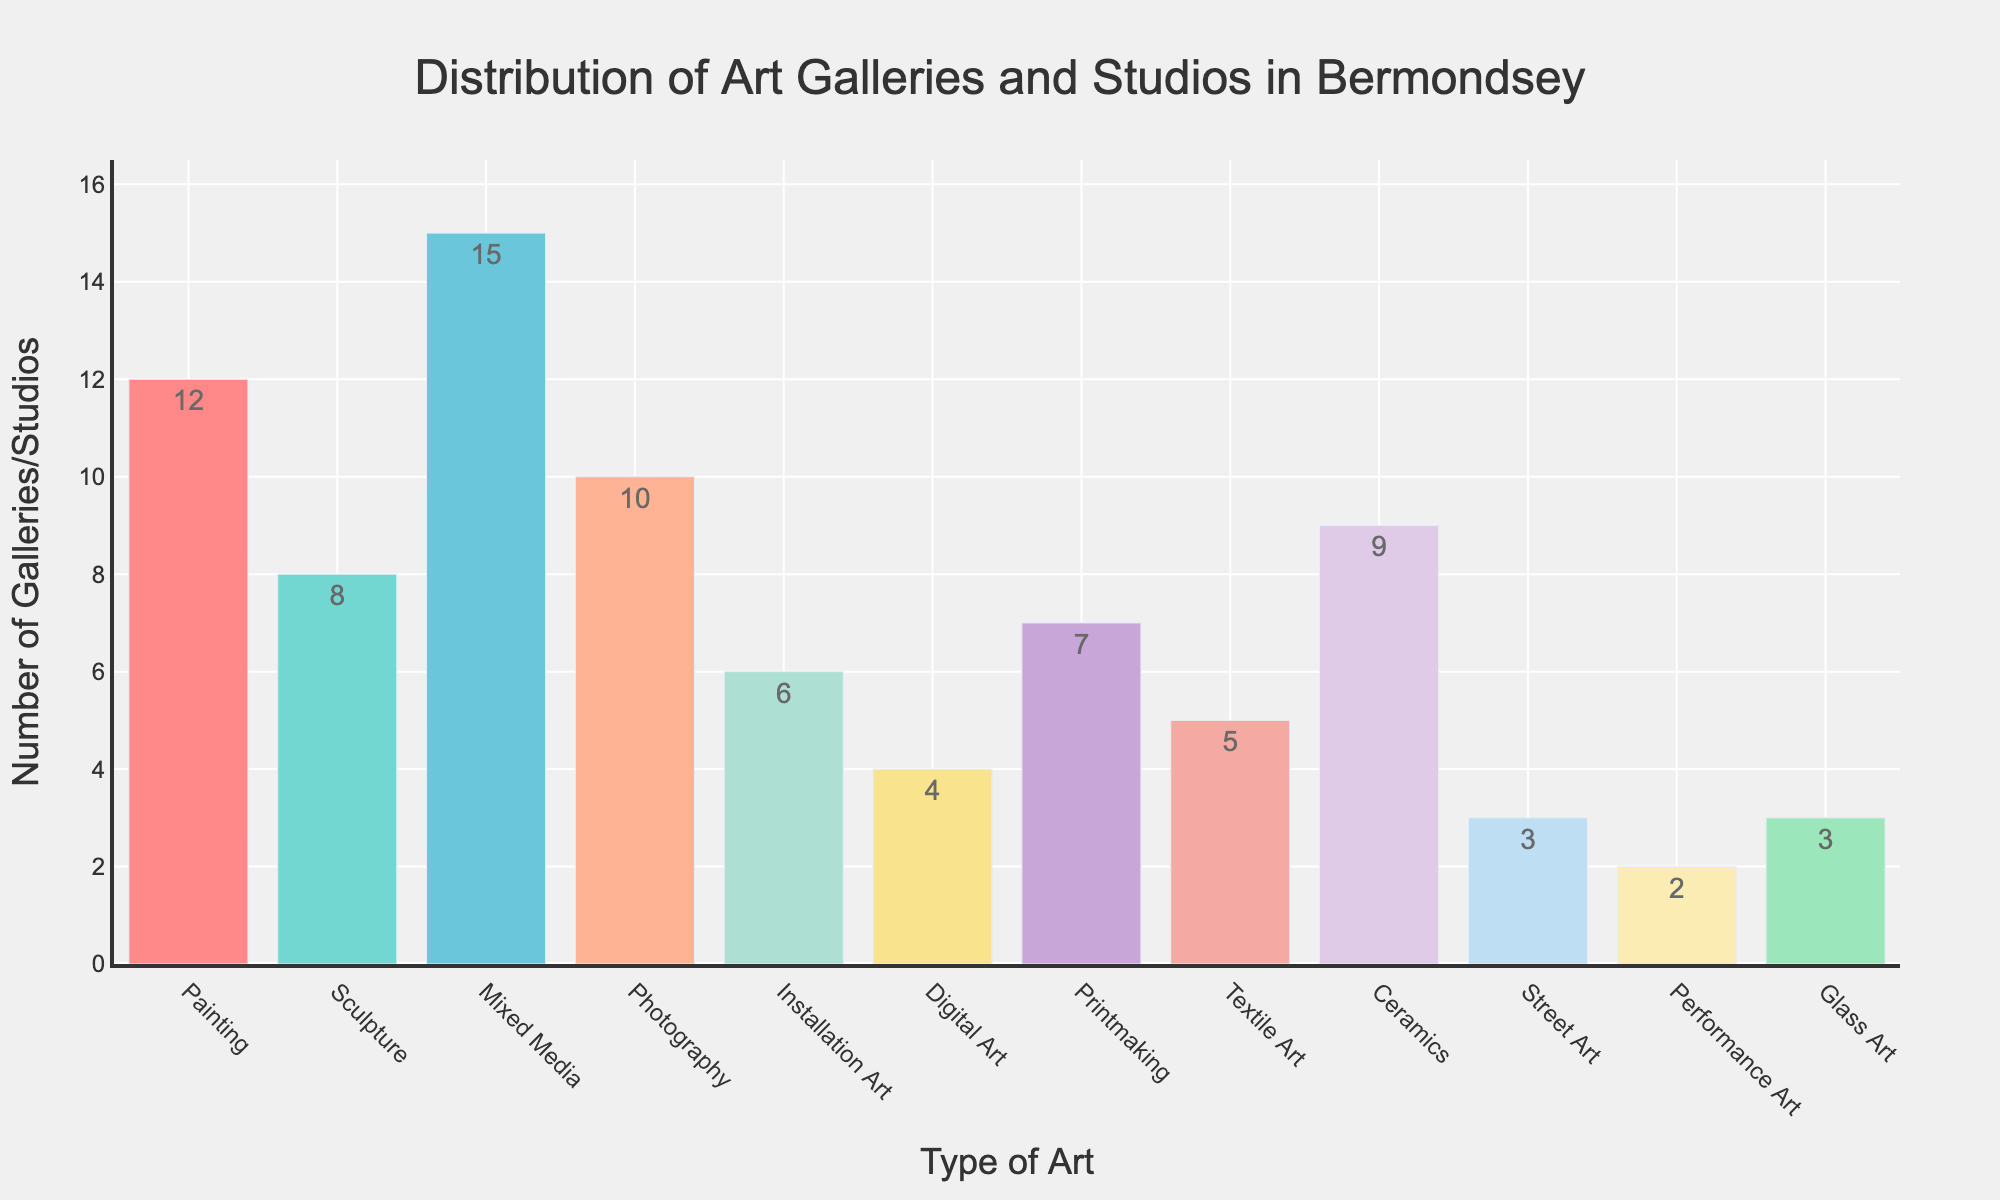What's the most common type of art gallery or studio in Bermondsey? The bar representing Mixed Media is the highest among all categories on the bar chart, indicating it is the most common type.
Answer: Mixed Media Which type of art gallery or studio is the least common in Bermondsey? The bar representing Performance Art is the shortest among all categories on the bar chart, indicating it is the least common type.
Answer: Performance Art How many more Painting galleries and studios are there compared to Sculpture ones? There are 12 Painting galleries and 8 Sculpture galleries. The difference is calculated as 12 - 8.
Answer: 4 What's the combined total number of Photography and Ceramics galleries and studios? There are 10 Photography galleries and 9 Ceramics galleries. The combined total is calculated as 10 + 9.
Answer: 19 Which type of art has a higher number of galleries and studios: Textile Art or Digital Art? The bar representing Textile Art is taller than that of Digital Art. Textile Art has 5 galleries while Digital Art has 4 galleries.
Answer: Textile Art What's the difference between the number of Mixed Media and Street Art galleries and studios? There are 15 Mixed Media galleries and 3 Street Art galleries. The difference is calculated as 15 - 3.
Answer: 12 What are the total number of galleries and studios for all types of art combined? Adding all the numbers: 12 (Painting) + 8 (Sculpture) + 15 (Mixed Media) + 10 (Photography) + 6 (Installation Art) + 4 (Digital Art) + 7 (Printmaking) + 5 (Textile Art) + 9 (Ceramics) + 3 (Street Art) + 2 (Performance Art) + 3 (Glass Art) = 84.
Answer: 84 Which type of art gallery or studio has twice the number of galleries as Digital Art? Digital Art has 4 galleries. The type of art with twice that number (8) is Sculpture.
Answer: Sculpture Among painting, sculpture, and mixed media, which type has the smallest number of galleries? The smallest number among these three is for Sculpture, which has 8 galleries.
Answer: Sculpture What is the difference in the number of Printmaking and Glass Art galleries and studios? Printmaking has 7 galleries, and Glass Art has 3. The difference is calculated as 7 - 3.
Answer: 4 